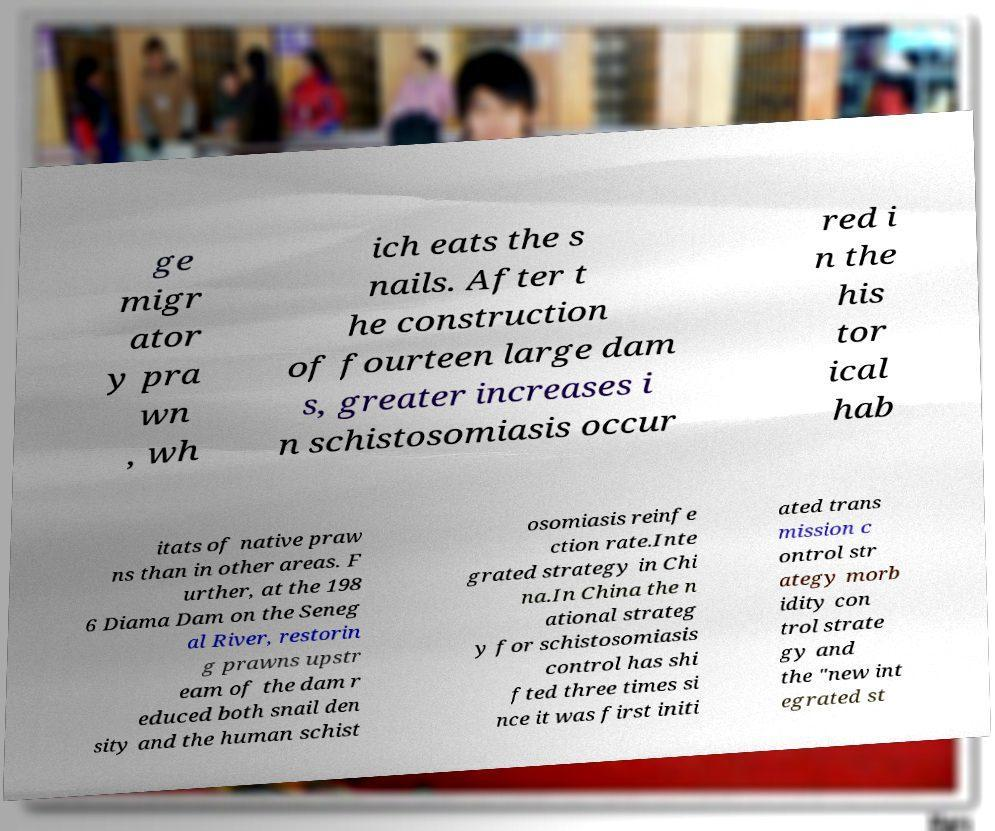Could you extract and type out the text from this image? ge migr ator y pra wn , wh ich eats the s nails. After t he construction of fourteen large dam s, greater increases i n schistosomiasis occur red i n the his tor ical hab itats of native praw ns than in other areas. F urther, at the 198 6 Diama Dam on the Seneg al River, restorin g prawns upstr eam of the dam r educed both snail den sity and the human schist osomiasis reinfe ction rate.Inte grated strategy in Chi na.In China the n ational strateg y for schistosomiasis control has shi fted three times si nce it was first initi ated trans mission c ontrol str ategy morb idity con trol strate gy and the "new int egrated st 